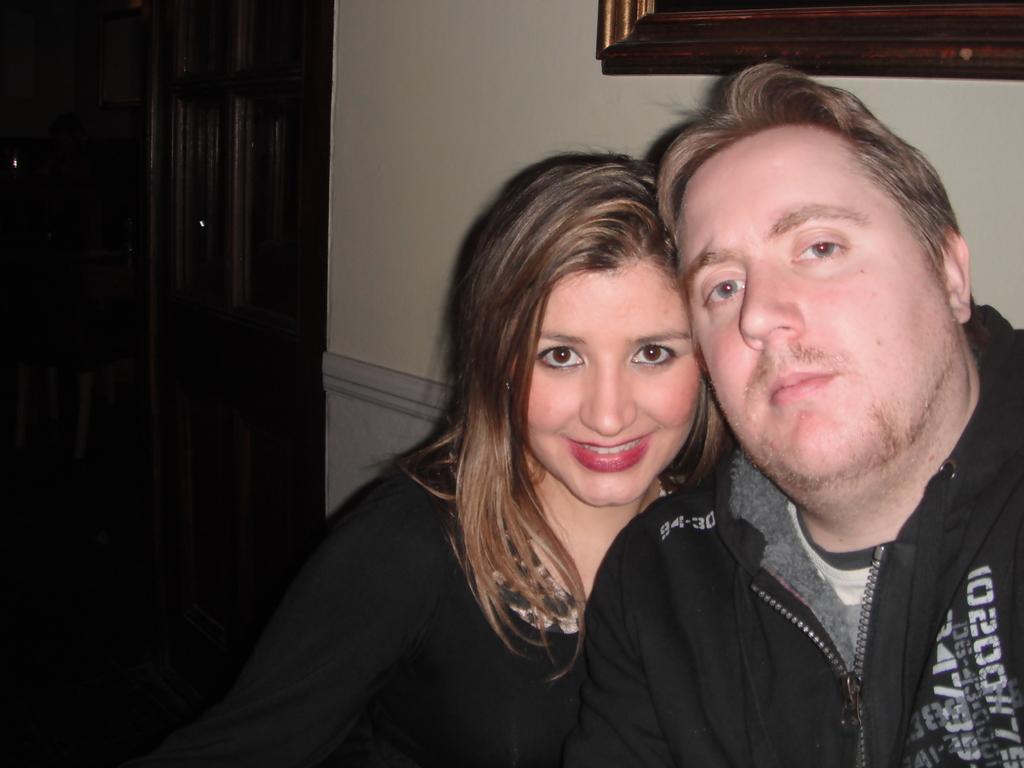Could you give a brief overview of what you see in this image? In the picture there are two people posing for the photo and behind them there is a wall and on the wall there is a frame and there is a door on the left side. 